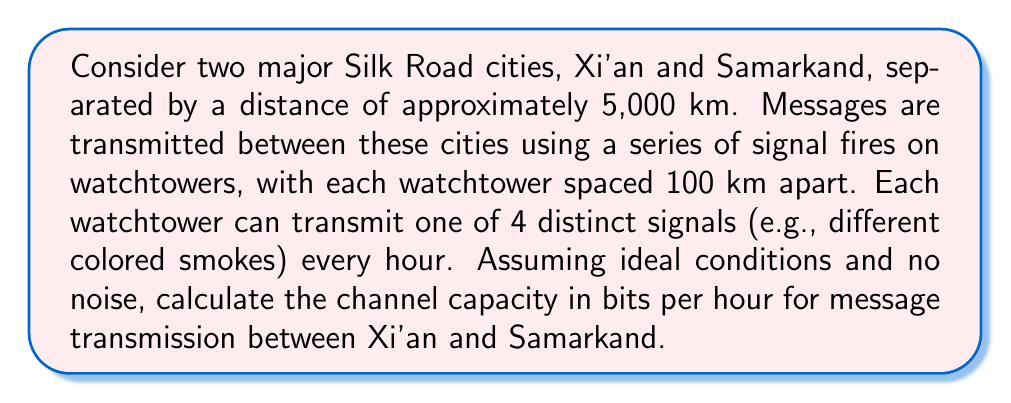Show me your answer to this math problem. To solve this problem, we'll use the Shannon-Hartley theorem for channel capacity. However, since we're assuming ideal conditions with no noise, we'll simplify our approach.

1. First, let's calculate the number of watchtowers:
   Number of watchtowers = Total distance / Distance between towers
   $$ N = \frac{5000 \text{ km}}{100 \text{ km}} = 50 \text{ watchtowers} $$

2. Each watchtower can transmit one of 4 distinct signals per hour. This means each tower can transmit 2 bits of information per hour:
   $$ \text{Bits per tower} = \log_2(4) = 2 \text{ bits} $$

3. The channel capacity is the product of the number of watchtowers and the bits each tower can transmit per hour:
   $$ C = N \times \text{Bits per tower} $$
   $$ C = 50 \times 2 = 100 \text{ bits per hour} $$

This result shows that despite the vast distance, a significant amount of information could theoretically be transmitted along the Silk Road using this system, highlighting the potential for long-distance communication in ancient trade networks.
Answer: The channel capacity for message transmission between Xi'an and Samarkand using the described signal fire system is 100 bits per hour. 